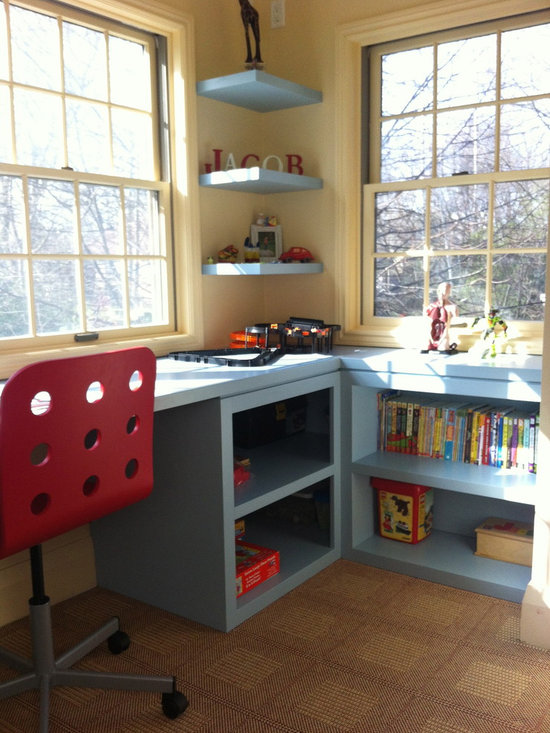What type of activities might typically take place at this desk? The desk appears to be used for a variety of activities suitable for a young child's developmental and recreational needs. These might include playing with toys such as the train set visible on the desk, reading books from the nearby shelves, engaging in arts and crafts activities, or using the computer for educational games and homework tasks. The arrangement of the space encourages a healthy blend of learning and play.  Could the set up of this room impact a child's learning or creativity? How? Certainly, the layout and items within this room are optimally arranged to stimulate a child’s learning and creative thinking. The ample natural light from the windows creates a welcoming and comfortable atmosphere, while the diverse range of books and toys supports both educational and creative pursuits. Specifically, a variety of reading materials can expand vocabulary and knowledge, while toys like the train set encourage problem-solving and innovative thinking. Additionally, the cozy, structured environment provides a safe space for a child to explore and express themselves artistically. 